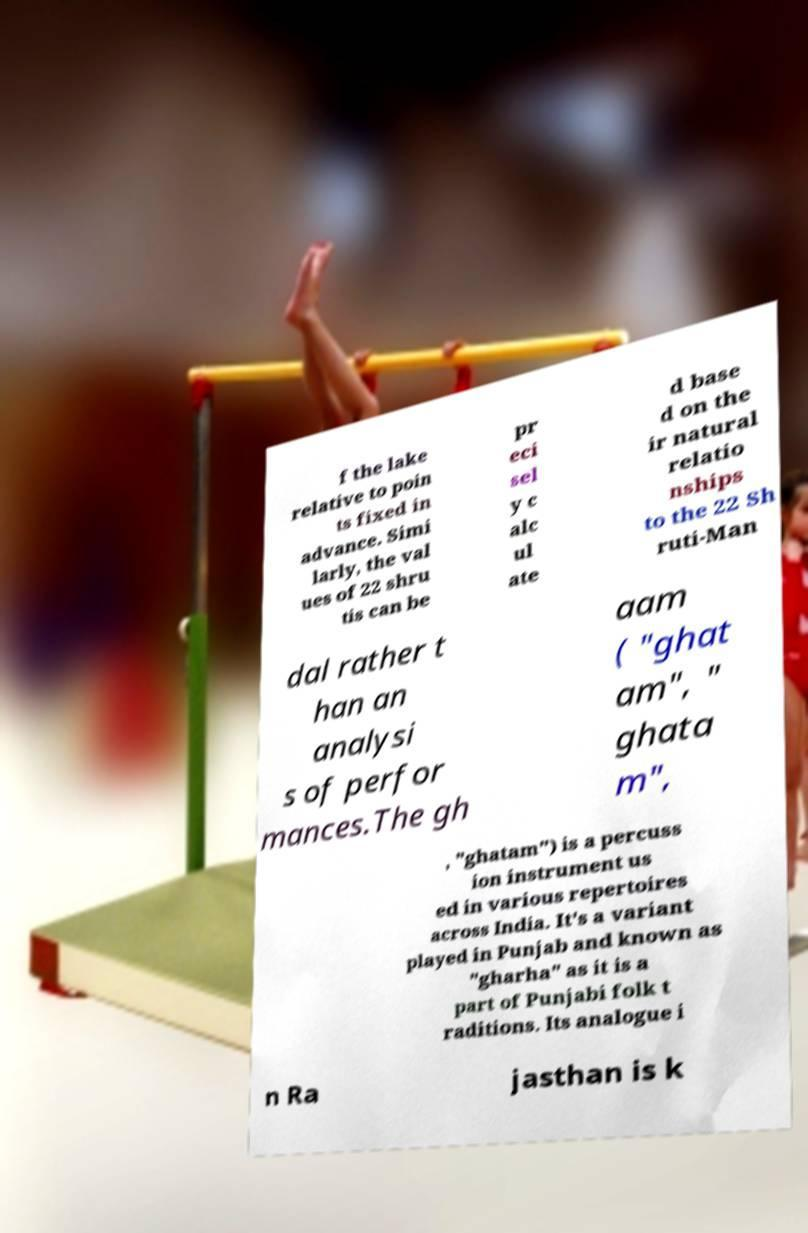What messages or text are displayed in this image? I need them in a readable, typed format. f the lake relative to poin ts fixed in advance. Simi larly, the val ues of 22 shru tis can be pr eci sel y c alc ul ate d base d on the ir natural relatio nships to the 22 Sh ruti-Man dal rather t han an analysi s of perfor mances.The gh aam ( "ghat am", " ghata m", , "ghatam") is a percuss ion instrument us ed in various repertoires across India. It's a variant played in Punjab and known as "gharha" as it is a part of Punjabi folk t raditions. Its analogue i n Ra jasthan is k 